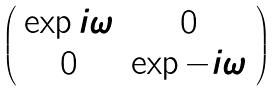<formula> <loc_0><loc_0><loc_500><loc_500>\left ( \begin{array} { c c } \exp { i \omega } & 0 \\ 0 & \exp { - i \omega } \end{array} \right )</formula> 